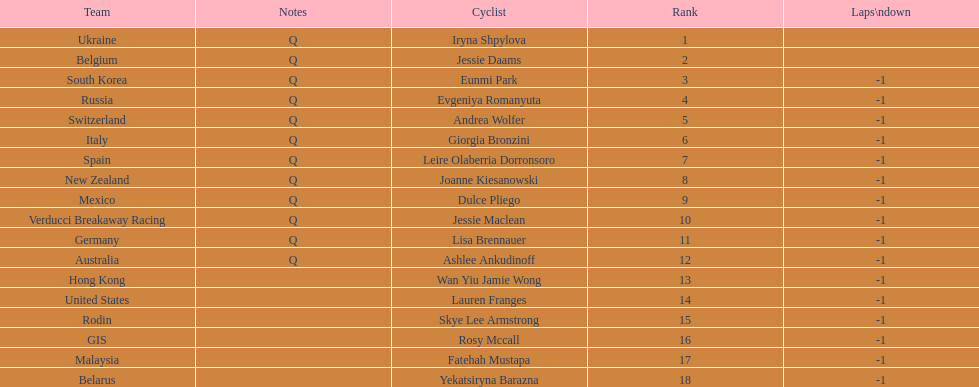Who is the last cyclist listed? Yekatsiryna Barazna. 